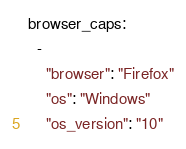<code> <loc_0><loc_0><loc_500><loc_500><_YAML_>browser_caps:
  -
    "browser": "Firefox"
    "os": "Windows"
    "os_version": "10"
</code> 